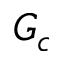<formula> <loc_0><loc_0><loc_500><loc_500>G _ { c }</formula> 